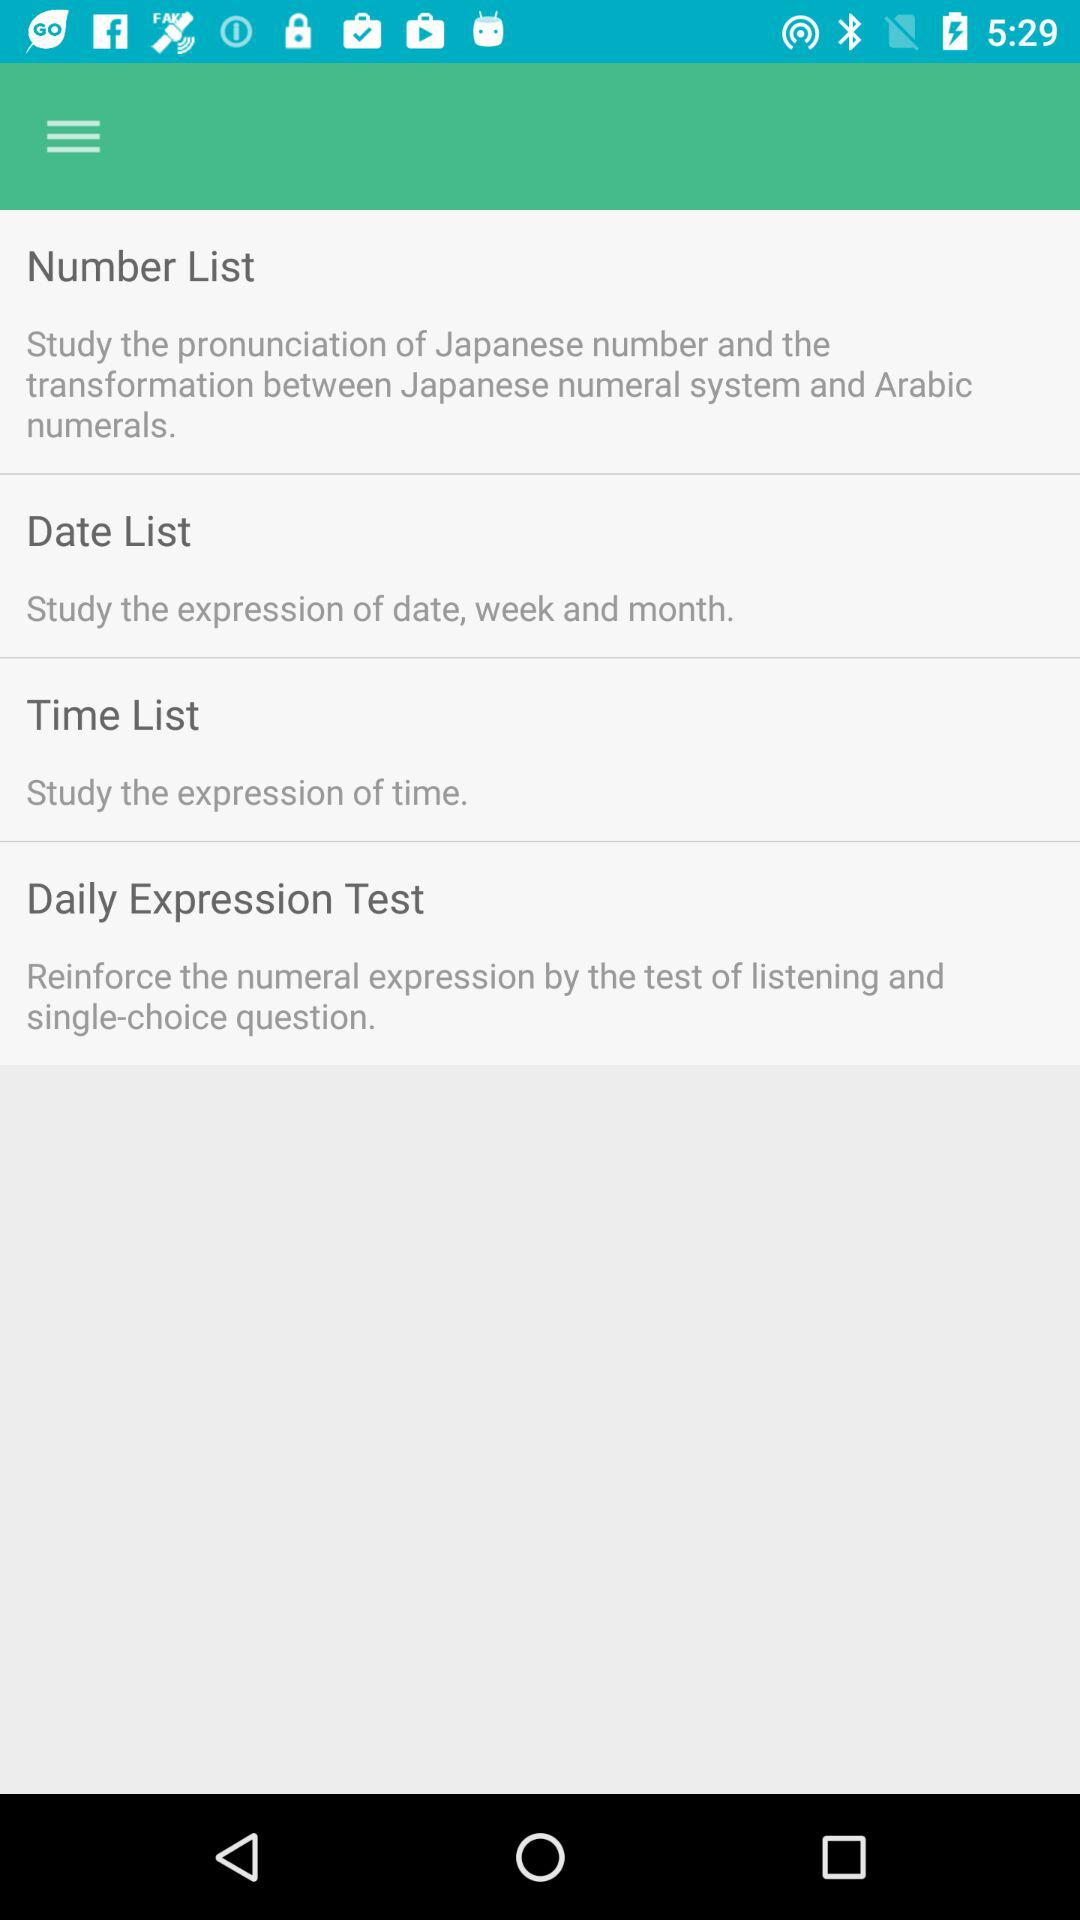Where can I study the expression of time? You can study the expression of time in "Time List". 